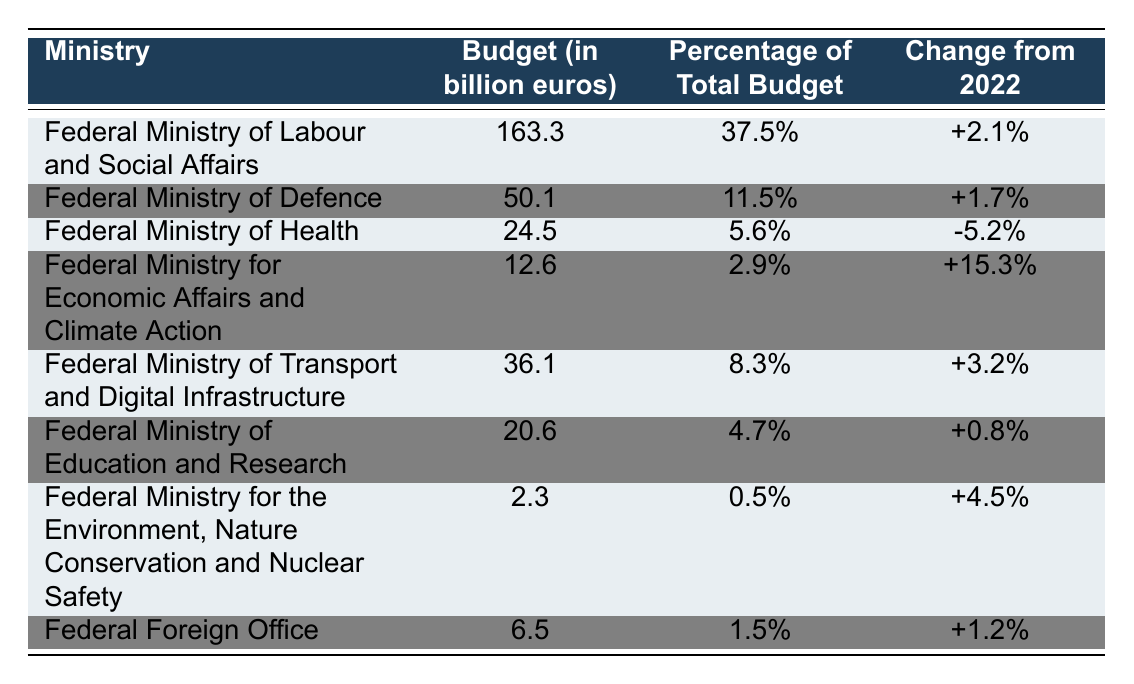What is the budget allocated to the Federal Ministry of Labour and Social Affairs? From the table, the budget for the Federal Ministry of Labour and Social Affairs is listed directly as 163.3 billion euros.
Answer: 163.3 billion euros Which ministry has the largest percentage of total budget allocation? The Federal Ministry of Labour and Social Affairs has a budget of 37.5%, which is higher than any other ministry listed in the table.
Answer: Federal Ministry of Labour and Social Affairs What is the change in budget for the Federal Ministry of Health from 2022? The table shows that the change in budget for the Federal Ministry of Health is a decrease of 5.2% from the previous year.
Answer: -5.2% What is the total budget allocated to the Federal Ministry for Economic Affairs and Climate Action and the Federal Ministry of Transport and Digital Infrastructure? The budget for the Federal Ministry for Economic Affairs and Climate Action is 12.6 billion euros, and for the Federal Ministry of Transport and Digital Infrastructure is 36.1 billion euros. Adding these gives: 12.6 + 36.1 = 48.7 billion euros.
Answer: 48.7 billion euros What percentage of the total budget does the Federal Foreign Office represent? The Federal Foreign Office has been allocated 1.5% of the total budget as per the table.
Answer: 1.5% Is the budget for the Federal Ministry of Health higher or lower than that of the Federal Ministry for Economic Affairs and Climate Action? The Federal Ministry of Health has a budget of 24.5 billion euros, while the Federal Ministry for Economic Affairs and Climate Action has a budget of 12.6 billion euros. Since 24.5 > 12.6, the budget for the Federal Ministry of Health is higher.
Answer: Higher What is the average budget allocation of the ministries listed in the table? To find the average, sum the budgets: 163.3 + 50.1 + 24.5 + 12.6 + 36.1 + 20.6 + 2.3 + 6.5 = 315.0 billion euros. There are 8 ministries, so the average is 315.0 / 8 = 39.375 billion euros.
Answer: 39.375 billion euros Which ministry saw the highest percentage increase in its budget from 2022? The Federal Ministry for Economic Affairs and Climate Action had the highest increase at +15.3%, which is the highest value listed in the 'Change from 2022' column.
Answer: Federal Ministry for Economic Affairs and Climate Action What was the total budget allocated for the Federal Ministry of Labour and Social Affairs and the Federal Ministry of Defence? The budget for the Federal Ministry of Labour and Social Affairs is 163.3 billion euros, and for the Federal Ministry of Defence is 50.1 billion euros. Therefore, adding them gives: 163.3 + 50.1 = 213.4 billion euros.
Answer: 213.4 billion euros Is the budget allocated to the Federal Ministry for the Environment, Nature Conservation and Nuclear Safety greater than 2 billion euros? The budget for the Federal Ministry for the Environment, Nature Conservation and Nuclear Safety is 2.3 billion euros, which is greater than 2 billion euros.
Answer: Yes 